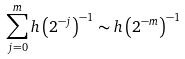<formula> <loc_0><loc_0><loc_500><loc_500>\sum _ { j = 0 } ^ { m } h \left ( 2 ^ { - j } \right ) ^ { - 1 } \sim h \left ( 2 ^ { - m } \right ) ^ { - 1 }</formula> 